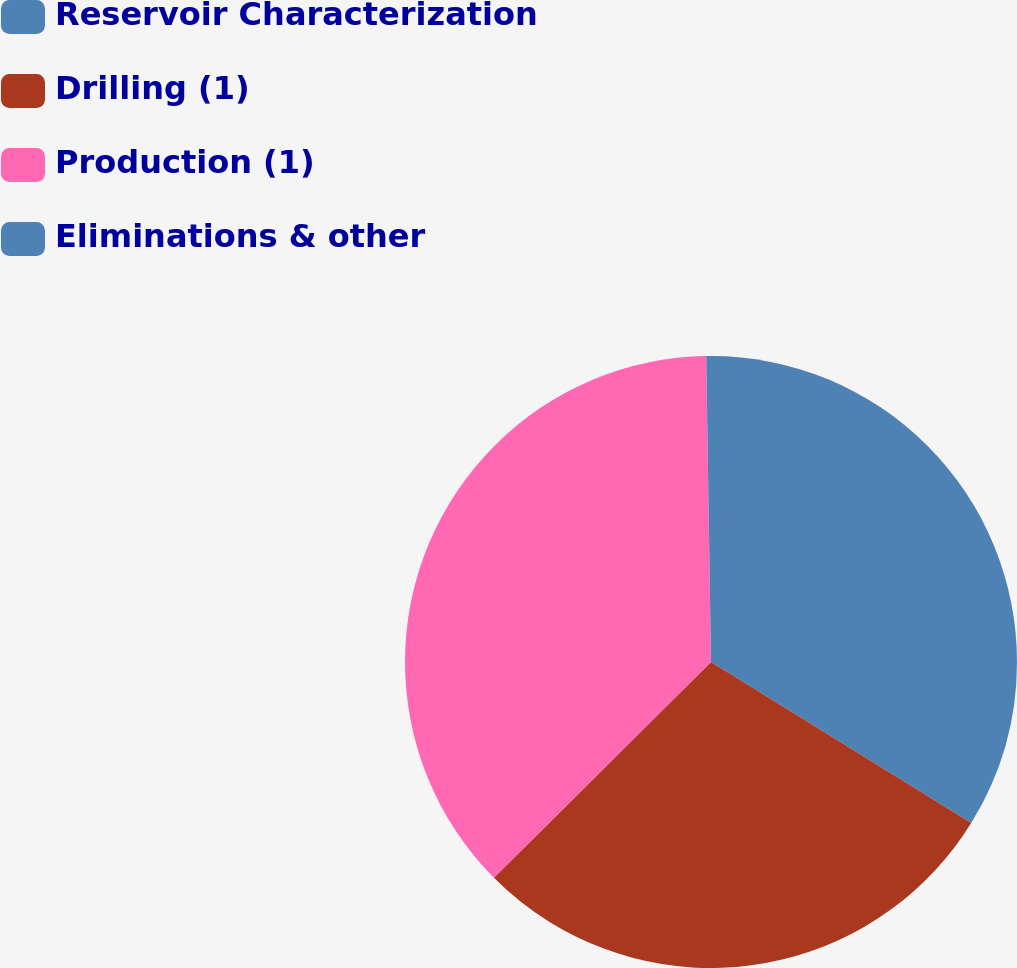Convert chart. <chart><loc_0><loc_0><loc_500><loc_500><pie_chart><fcel>Reservoir Characterization<fcel>Drilling (1)<fcel>Production (1)<fcel>Eliminations & other<nl><fcel>33.82%<fcel>28.73%<fcel>37.2%<fcel>0.25%<nl></chart> 